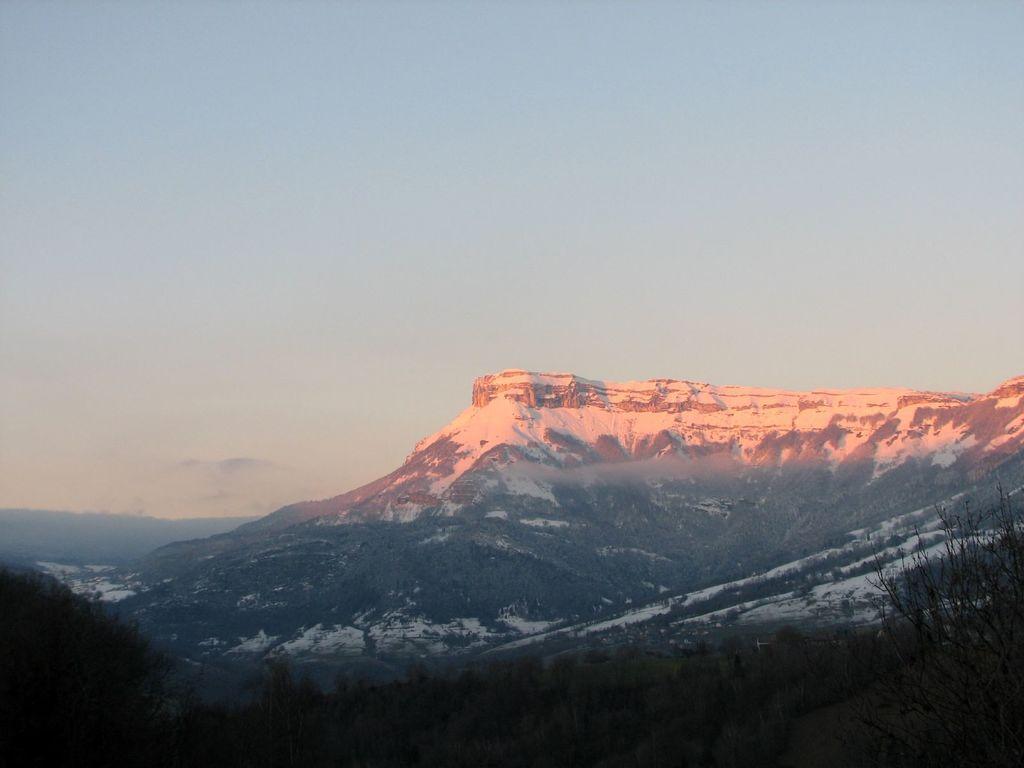In one or two sentences, can you explain what this image depicts? In this image, we can see some hills with snow. We can see some trees and plants. We can also see the sky. 